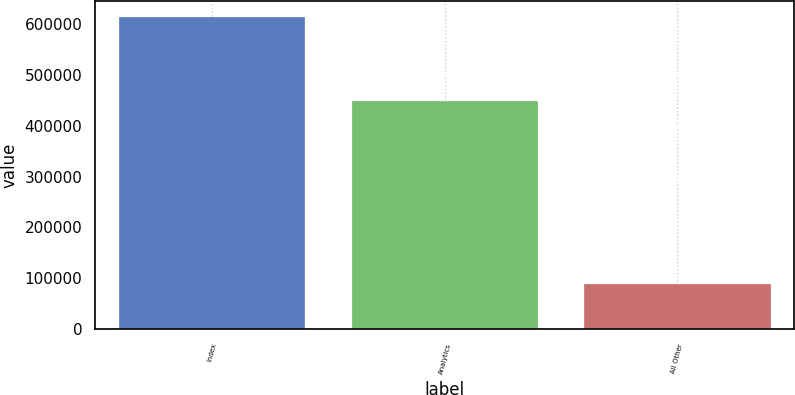<chart> <loc_0><loc_0><loc_500><loc_500><bar_chart><fcel>Index<fcel>Analytics<fcel>All Other<nl><fcel>613551<fcel>448353<fcel>88765<nl></chart> 